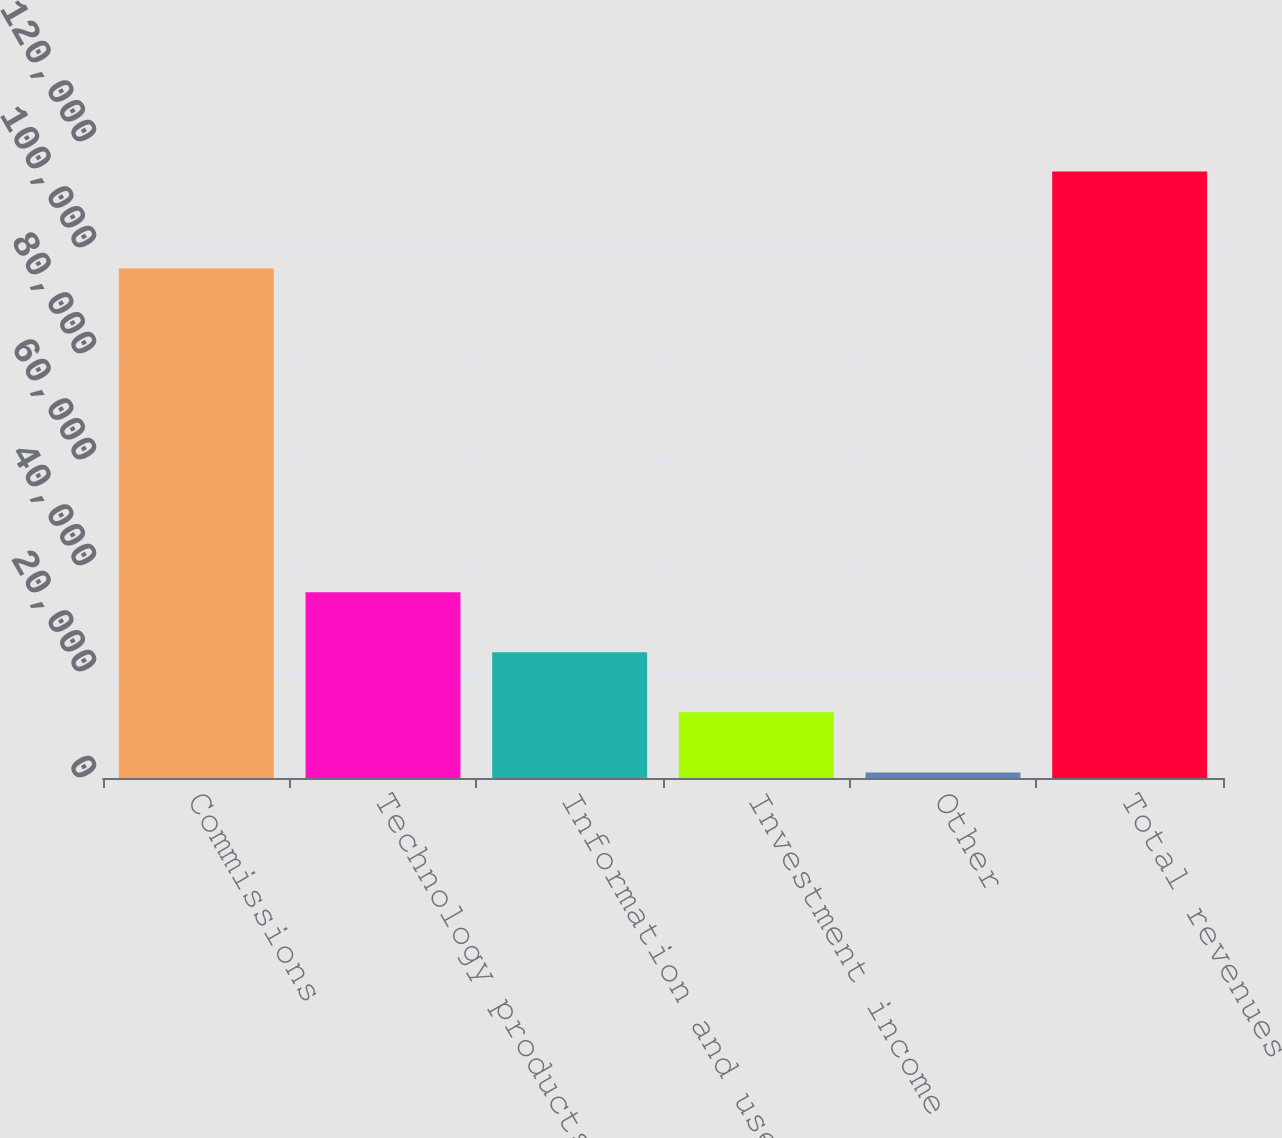Convert chart. <chart><loc_0><loc_0><loc_500><loc_500><bar_chart><fcel>Commissions<fcel>Technology products and<fcel>Information and user access<fcel>Investment income<fcel>Other<fcel>Total revenues<nl><fcel>96132<fcel>35070.2<fcel>23731.8<fcel>12393.4<fcel>1055<fcel>114439<nl></chart> 